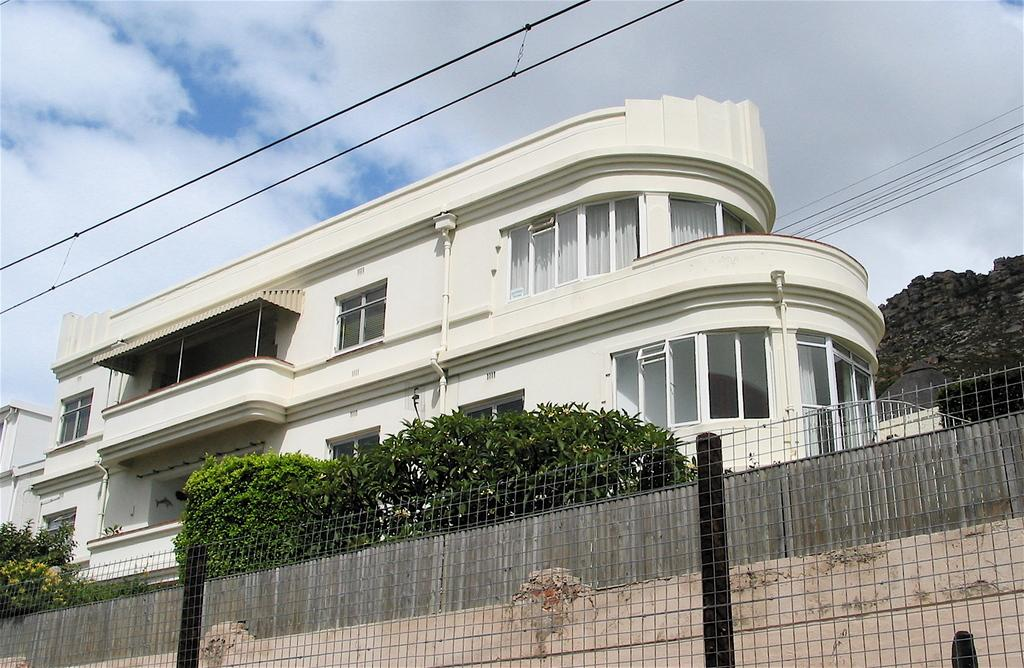What type of structures can be seen in the image? There are buildings in the image. What other natural elements are present in the image? There are trees in the image. What man-made objects can be seen connecting the structures? Cables are present in the image. What architectural features are visible on the buildings? There are windows in the image. What infrastructure elements can be seen in the image? Pipes are visible in the image. What type of barrier is present in the image? There is fencing in the image. What can be seen in the background of the image? The sky is visible in the background of the image. What type of skirt is hanging on the tree in the image? There is no skirt present in the image; it features buildings, trees, cables, windows, pipes, fencing, and the sky. What color is the sheet draped over the fence in the image? There is no sheet present in the image; it only features the mentioned elements. 